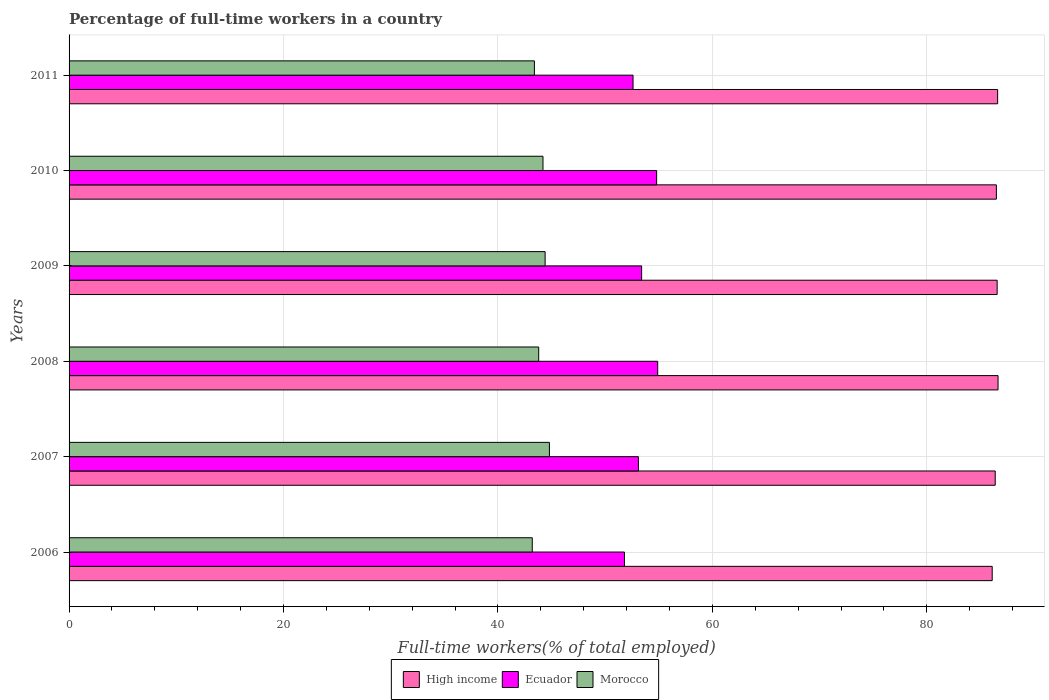How many different coloured bars are there?
Your answer should be compact. 3. How many bars are there on the 5th tick from the top?
Offer a terse response. 3. How many bars are there on the 3rd tick from the bottom?
Give a very brief answer. 3. What is the percentage of full-time workers in Ecuador in 2010?
Your answer should be compact. 54.8. Across all years, what is the maximum percentage of full-time workers in High income?
Offer a terse response. 86.64. Across all years, what is the minimum percentage of full-time workers in Morocco?
Your response must be concise. 43.2. What is the total percentage of full-time workers in Morocco in the graph?
Make the answer very short. 263.8. What is the difference between the percentage of full-time workers in Ecuador in 2006 and that in 2011?
Your response must be concise. -0.8. What is the difference between the percentage of full-time workers in Ecuador in 2010 and the percentage of full-time workers in Morocco in 2011?
Keep it short and to the point. 11.4. What is the average percentage of full-time workers in Morocco per year?
Offer a terse response. 43.97. In the year 2007, what is the difference between the percentage of full-time workers in Morocco and percentage of full-time workers in Ecuador?
Provide a succinct answer. -8.3. What is the ratio of the percentage of full-time workers in Ecuador in 2009 to that in 2010?
Your answer should be very brief. 0.97. Is the percentage of full-time workers in Ecuador in 2006 less than that in 2010?
Ensure brevity in your answer.  Yes. Is the difference between the percentage of full-time workers in Morocco in 2010 and 2011 greater than the difference between the percentage of full-time workers in Ecuador in 2010 and 2011?
Keep it short and to the point. No. What is the difference between the highest and the second highest percentage of full-time workers in Morocco?
Keep it short and to the point. 0.4. What is the difference between the highest and the lowest percentage of full-time workers in Ecuador?
Give a very brief answer. 3.1. In how many years, is the percentage of full-time workers in Morocco greater than the average percentage of full-time workers in Morocco taken over all years?
Provide a succinct answer. 3. Is the sum of the percentage of full-time workers in High income in 2006 and 2007 greater than the maximum percentage of full-time workers in Ecuador across all years?
Ensure brevity in your answer.  Yes. What does the 1st bar from the top in 2006 represents?
Provide a short and direct response. Morocco. What does the 2nd bar from the bottom in 2009 represents?
Give a very brief answer. Ecuador. How many bars are there?
Provide a succinct answer. 18. Are all the bars in the graph horizontal?
Ensure brevity in your answer.  Yes. Does the graph contain any zero values?
Make the answer very short. No. What is the title of the graph?
Make the answer very short. Percentage of full-time workers in a country. Does "Argentina" appear as one of the legend labels in the graph?
Make the answer very short. No. What is the label or title of the X-axis?
Keep it short and to the point. Full-time workers(% of total employed). What is the Full-time workers(% of total employed) in High income in 2006?
Make the answer very short. 86.1. What is the Full-time workers(% of total employed) in Ecuador in 2006?
Offer a very short reply. 51.8. What is the Full-time workers(% of total employed) of Morocco in 2006?
Ensure brevity in your answer.  43.2. What is the Full-time workers(% of total employed) in High income in 2007?
Offer a terse response. 86.38. What is the Full-time workers(% of total employed) of Ecuador in 2007?
Offer a terse response. 53.1. What is the Full-time workers(% of total employed) of Morocco in 2007?
Give a very brief answer. 44.8. What is the Full-time workers(% of total employed) of High income in 2008?
Your answer should be very brief. 86.64. What is the Full-time workers(% of total employed) of Ecuador in 2008?
Your answer should be compact. 54.9. What is the Full-time workers(% of total employed) in Morocco in 2008?
Offer a terse response. 43.8. What is the Full-time workers(% of total employed) in High income in 2009?
Your answer should be very brief. 86.56. What is the Full-time workers(% of total employed) of Ecuador in 2009?
Your answer should be very brief. 53.4. What is the Full-time workers(% of total employed) in Morocco in 2009?
Offer a very short reply. 44.4. What is the Full-time workers(% of total employed) in High income in 2010?
Offer a very short reply. 86.49. What is the Full-time workers(% of total employed) of Ecuador in 2010?
Make the answer very short. 54.8. What is the Full-time workers(% of total employed) of Morocco in 2010?
Ensure brevity in your answer.  44.2. What is the Full-time workers(% of total employed) of High income in 2011?
Make the answer very short. 86.61. What is the Full-time workers(% of total employed) of Ecuador in 2011?
Keep it short and to the point. 52.6. What is the Full-time workers(% of total employed) in Morocco in 2011?
Offer a very short reply. 43.4. Across all years, what is the maximum Full-time workers(% of total employed) in High income?
Provide a short and direct response. 86.64. Across all years, what is the maximum Full-time workers(% of total employed) in Ecuador?
Your answer should be very brief. 54.9. Across all years, what is the maximum Full-time workers(% of total employed) of Morocco?
Ensure brevity in your answer.  44.8. Across all years, what is the minimum Full-time workers(% of total employed) of High income?
Give a very brief answer. 86.1. Across all years, what is the minimum Full-time workers(% of total employed) in Ecuador?
Provide a short and direct response. 51.8. Across all years, what is the minimum Full-time workers(% of total employed) in Morocco?
Your answer should be compact. 43.2. What is the total Full-time workers(% of total employed) in High income in the graph?
Your answer should be very brief. 518.77. What is the total Full-time workers(% of total employed) in Ecuador in the graph?
Ensure brevity in your answer.  320.6. What is the total Full-time workers(% of total employed) of Morocco in the graph?
Your answer should be compact. 263.8. What is the difference between the Full-time workers(% of total employed) in High income in 2006 and that in 2007?
Your response must be concise. -0.28. What is the difference between the Full-time workers(% of total employed) in Morocco in 2006 and that in 2007?
Offer a terse response. -1.6. What is the difference between the Full-time workers(% of total employed) of High income in 2006 and that in 2008?
Provide a short and direct response. -0.54. What is the difference between the Full-time workers(% of total employed) of Ecuador in 2006 and that in 2008?
Your answer should be compact. -3.1. What is the difference between the Full-time workers(% of total employed) in High income in 2006 and that in 2009?
Offer a very short reply. -0.46. What is the difference between the Full-time workers(% of total employed) in High income in 2006 and that in 2010?
Offer a terse response. -0.39. What is the difference between the Full-time workers(% of total employed) of High income in 2006 and that in 2011?
Provide a succinct answer. -0.51. What is the difference between the Full-time workers(% of total employed) in Ecuador in 2006 and that in 2011?
Give a very brief answer. -0.8. What is the difference between the Full-time workers(% of total employed) of Morocco in 2006 and that in 2011?
Ensure brevity in your answer.  -0.2. What is the difference between the Full-time workers(% of total employed) in High income in 2007 and that in 2008?
Make the answer very short. -0.26. What is the difference between the Full-time workers(% of total employed) of Ecuador in 2007 and that in 2008?
Ensure brevity in your answer.  -1.8. What is the difference between the Full-time workers(% of total employed) of Morocco in 2007 and that in 2008?
Your response must be concise. 1. What is the difference between the Full-time workers(% of total employed) in High income in 2007 and that in 2009?
Your answer should be compact. -0.18. What is the difference between the Full-time workers(% of total employed) in Ecuador in 2007 and that in 2009?
Make the answer very short. -0.3. What is the difference between the Full-time workers(% of total employed) in High income in 2007 and that in 2010?
Provide a succinct answer. -0.11. What is the difference between the Full-time workers(% of total employed) in Ecuador in 2007 and that in 2010?
Your answer should be compact. -1.7. What is the difference between the Full-time workers(% of total employed) in High income in 2007 and that in 2011?
Your answer should be very brief. -0.23. What is the difference between the Full-time workers(% of total employed) in Ecuador in 2007 and that in 2011?
Offer a very short reply. 0.5. What is the difference between the Full-time workers(% of total employed) of Morocco in 2007 and that in 2011?
Keep it short and to the point. 1.4. What is the difference between the Full-time workers(% of total employed) in High income in 2008 and that in 2009?
Ensure brevity in your answer.  0.08. What is the difference between the Full-time workers(% of total employed) in Ecuador in 2008 and that in 2009?
Provide a short and direct response. 1.5. What is the difference between the Full-time workers(% of total employed) of Morocco in 2008 and that in 2009?
Your response must be concise. -0.6. What is the difference between the Full-time workers(% of total employed) in High income in 2008 and that in 2010?
Offer a terse response. 0.16. What is the difference between the Full-time workers(% of total employed) of High income in 2008 and that in 2011?
Give a very brief answer. 0.04. What is the difference between the Full-time workers(% of total employed) in Ecuador in 2008 and that in 2011?
Provide a short and direct response. 2.3. What is the difference between the Full-time workers(% of total employed) in Morocco in 2008 and that in 2011?
Ensure brevity in your answer.  0.4. What is the difference between the Full-time workers(% of total employed) in High income in 2009 and that in 2010?
Your response must be concise. 0.07. What is the difference between the Full-time workers(% of total employed) in Morocco in 2009 and that in 2010?
Your answer should be compact. 0.2. What is the difference between the Full-time workers(% of total employed) in High income in 2009 and that in 2011?
Offer a terse response. -0.05. What is the difference between the Full-time workers(% of total employed) in Ecuador in 2009 and that in 2011?
Your answer should be very brief. 0.8. What is the difference between the Full-time workers(% of total employed) of High income in 2010 and that in 2011?
Ensure brevity in your answer.  -0.12. What is the difference between the Full-time workers(% of total employed) of Ecuador in 2010 and that in 2011?
Keep it short and to the point. 2.2. What is the difference between the Full-time workers(% of total employed) of Morocco in 2010 and that in 2011?
Your answer should be very brief. 0.8. What is the difference between the Full-time workers(% of total employed) in High income in 2006 and the Full-time workers(% of total employed) in Ecuador in 2007?
Provide a succinct answer. 33. What is the difference between the Full-time workers(% of total employed) in High income in 2006 and the Full-time workers(% of total employed) in Morocco in 2007?
Ensure brevity in your answer.  41.3. What is the difference between the Full-time workers(% of total employed) in High income in 2006 and the Full-time workers(% of total employed) in Ecuador in 2008?
Offer a terse response. 31.2. What is the difference between the Full-time workers(% of total employed) of High income in 2006 and the Full-time workers(% of total employed) of Morocco in 2008?
Make the answer very short. 42.3. What is the difference between the Full-time workers(% of total employed) in High income in 2006 and the Full-time workers(% of total employed) in Ecuador in 2009?
Give a very brief answer. 32.7. What is the difference between the Full-time workers(% of total employed) of High income in 2006 and the Full-time workers(% of total employed) of Morocco in 2009?
Ensure brevity in your answer.  41.7. What is the difference between the Full-time workers(% of total employed) of Ecuador in 2006 and the Full-time workers(% of total employed) of Morocco in 2009?
Offer a very short reply. 7.4. What is the difference between the Full-time workers(% of total employed) of High income in 2006 and the Full-time workers(% of total employed) of Ecuador in 2010?
Ensure brevity in your answer.  31.3. What is the difference between the Full-time workers(% of total employed) of High income in 2006 and the Full-time workers(% of total employed) of Morocco in 2010?
Your answer should be very brief. 41.9. What is the difference between the Full-time workers(% of total employed) in Ecuador in 2006 and the Full-time workers(% of total employed) in Morocco in 2010?
Your answer should be very brief. 7.6. What is the difference between the Full-time workers(% of total employed) in High income in 2006 and the Full-time workers(% of total employed) in Ecuador in 2011?
Your answer should be very brief. 33.5. What is the difference between the Full-time workers(% of total employed) in High income in 2006 and the Full-time workers(% of total employed) in Morocco in 2011?
Your answer should be very brief. 42.7. What is the difference between the Full-time workers(% of total employed) in Ecuador in 2006 and the Full-time workers(% of total employed) in Morocco in 2011?
Give a very brief answer. 8.4. What is the difference between the Full-time workers(% of total employed) in High income in 2007 and the Full-time workers(% of total employed) in Ecuador in 2008?
Give a very brief answer. 31.48. What is the difference between the Full-time workers(% of total employed) of High income in 2007 and the Full-time workers(% of total employed) of Morocco in 2008?
Provide a succinct answer. 42.58. What is the difference between the Full-time workers(% of total employed) in High income in 2007 and the Full-time workers(% of total employed) in Ecuador in 2009?
Offer a terse response. 32.98. What is the difference between the Full-time workers(% of total employed) of High income in 2007 and the Full-time workers(% of total employed) of Morocco in 2009?
Provide a short and direct response. 41.98. What is the difference between the Full-time workers(% of total employed) of Ecuador in 2007 and the Full-time workers(% of total employed) of Morocco in 2009?
Your response must be concise. 8.7. What is the difference between the Full-time workers(% of total employed) of High income in 2007 and the Full-time workers(% of total employed) of Ecuador in 2010?
Your answer should be compact. 31.58. What is the difference between the Full-time workers(% of total employed) of High income in 2007 and the Full-time workers(% of total employed) of Morocco in 2010?
Your answer should be compact. 42.18. What is the difference between the Full-time workers(% of total employed) in High income in 2007 and the Full-time workers(% of total employed) in Ecuador in 2011?
Your answer should be compact. 33.78. What is the difference between the Full-time workers(% of total employed) of High income in 2007 and the Full-time workers(% of total employed) of Morocco in 2011?
Provide a short and direct response. 42.98. What is the difference between the Full-time workers(% of total employed) in High income in 2008 and the Full-time workers(% of total employed) in Ecuador in 2009?
Keep it short and to the point. 33.24. What is the difference between the Full-time workers(% of total employed) in High income in 2008 and the Full-time workers(% of total employed) in Morocco in 2009?
Make the answer very short. 42.24. What is the difference between the Full-time workers(% of total employed) in High income in 2008 and the Full-time workers(% of total employed) in Ecuador in 2010?
Make the answer very short. 31.84. What is the difference between the Full-time workers(% of total employed) in High income in 2008 and the Full-time workers(% of total employed) in Morocco in 2010?
Make the answer very short. 42.44. What is the difference between the Full-time workers(% of total employed) of Ecuador in 2008 and the Full-time workers(% of total employed) of Morocco in 2010?
Provide a short and direct response. 10.7. What is the difference between the Full-time workers(% of total employed) in High income in 2008 and the Full-time workers(% of total employed) in Ecuador in 2011?
Give a very brief answer. 34.04. What is the difference between the Full-time workers(% of total employed) of High income in 2008 and the Full-time workers(% of total employed) of Morocco in 2011?
Offer a terse response. 43.24. What is the difference between the Full-time workers(% of total employed) in High income in 2009 and the Full-time workers(% of total employed) in Ecuador in 2010?
Offer a terse response. 31.76. What is the difference between the Full-time workers(% of total employed) in High income in 2009 and the Full-time workers(% of total employed) in Morocco in 2010?
Provide a short and direct response. 42.36. What is the difference between the Full-time workers(% of total employed) in Ecuador in 2009 and the Full-time workers(% of total employed) in Morocco in 2010?
Keep it short and to the point. 9.2. What is the difference between the Full-time workers(% of total employed) in High income in 2009 and the Full-time workers(% of total employed) in Ecuador in 2011?
Offer a terse response. 33.96. What is the difference between the Full-time workers(% of total employed) in High income in 2009 and the Full-time workers(% of total employed) in Morocco in 2011?
Keep it short and to the point. 43.16. What is the difference between the Full-time workers(% of total employed) of Ecuador in 2009 and the Full-time workers(% of total employed) of Morocco in 2011?
Provide a succinct answer. 10. What is the difference between the Full-time workers(% of total employed) in High income in 2010 and the Full-time workers(% of total employed) in Ecuador in 2011?
Give a very brief answer. 33.89. What is the difference between the Full-time workers(% of total employed) of High income in 2010 and the Full-time workers(% of total employed) of Morocco in 2011?
Offer a terse response. 43.09. What is the difference between the Full-time workers(% of total employed) of Ecuador in 2010 and the Full-time workers(% of total employed) of Morocco in 2011?
Offer a terse response. 11.4. What is the average Full-time workers(% of total employed) in High income per year?
Offer a terse response. 86.46. What is the average Full-time workers(% of total employed) of Ecuador per year?
Your answer should be very brief. 53.43. What is the average Full-time workers(% of total employed) of Morocco per year?
Make the answer very short. 43.97. In the year 2006, what is the difference between the Full-time workers(% of total employed) of High income and Full-time workers(% of total employed) of Ecuador?
Offer a very short reply. 34.3. In the year 2006, what is the difference between the Full-time workers(% of total employed) of High income and Full-time workers(% of total employed) of Morocco?
Ensure brevity in your answer.  42.9. In the year 2007, what is the difference between the Full-time workers(% of total employed) in High income and Full-time workers(% of total employed) in Ecuador?
Your answer should be very brief. 33.28. In the year 2007, what is the difference between the Full-time workers(% of total employed) in High income and Full-time workers(% of total employed) in Morocco?
Your response must be concise. 41.58. In the year 2007, what is the difference between the Full-time workers(% of total employed) of Ecuador and Full-time workers(% of total employed) of Morocco?
Offer a terse response. 8.3. In the year 2008, what is the difference between the Full-time workers(% of total employed) in High income and Full-time workers(% of total employed) in Ecuador?
Provide a short and direct response. 31.74. In the year 2008, what is the difference between the Full-time workers(% of total employed) of High income and Full-time workers(% of total employed) of Morocco?
Your answer should be very brief. 42.84. In the year 2009, what is the difference between the Full-time workers(% of total employed) of High income and Full-time workers(% of total employed) of Ecuador?
Give a very brief answer. 33.16. In the year 2009, what is the difference between the Full-time workers(% of total employed) of High income and Full-time workers(% of total employed) of Morocco?
Give a very brief answer. 42.16. In the year 2009, what is the difference between the Full-time workers(% of total employed) in Ecuador and Full-time workers(% of total employed) in Morocco?
Your answer should be compact. 9. In the year 2010, what is the difference between the Full-time workers(% of total employed) of High income and Full-time workers(% of total employed) of Ecuador?
Your response must be concise. 31.69. In the year 2010, what is the difference between the Full-time workers(% of total employed) of High income and Full-time workers(% of total employed) of Morocco?
Provide a succinct answer. 42.29. In the year 2010, what is the difference between the Full-time workers(% of total employed) of Ecuador and Full-time workers(% of total employed) of Morocco?
Ensure brevity in your answer.  10.6. In the year 2011, what is the difference between the Full-time workers(% of total employed) in High income and Full-time workers(% of total employed) in Ecuador?
Provide a short and direct response. 34.01. In the year 2011, what is the difference between the Full-time workers(% of total employed) in High income and Full-time workers(% of total employed) in Morocco?
Ensure brevity in your answer.  43.2. In the year 2011, what is the difference between the Full-time workers(% of total employed) of Ecuador and Full-time workers(% of total employed) of Morocco?
Your answer should be compact. 9.2. What is the ratio of the Full-time workers(% of total employed) of Ecuador in 2006 to that in 2007?
Provide a short and direct response. 0.98. What is the ratio of the Full-time workers(% of total employed) of Ecuador in 2006 to that in 2008?
Your response must be concise. 0.94. What is the ratio of the Full-time workers(% of total employed) in Morocco in 2006 to that in 2008?
Your response must be concise. 0.99. What is the ratio of the Full-time workers(% of total employed) of High income in 2006 to that in 2009?
Your response must be concise. 0.99. What is the ratio of the Full-time workers(% of total employed) in Ecuador in 2006 to that in 2009?
Make the answer very short. 0.97. What is the ratio of the Full-time workers(% of total employed) in Morocco in 2006 to that in 2009?
Provide a short and direct response. 0.97. What is the ratio of the Full-time workers(% of total employed) in Ecuador in 2006 to that in 2010?
Provide a succinct answer. 0.95. What is the ratio of the Full-time workers(% of total employed) of Morocco in 2006 to that in 2010?
Provide a short and direct response. 0.98. What is the ratio of the Full-time workers(% of total employed) of High income in 2006 to that in 2011?
Provide a succinct answer. 0.99. What is the ratio of the Full-time workers(% of total employed) in Morocco in 2006 to that in 2011?
Offer a very short reply. 1. What is the ratio of the Full-time workers(% of total employed) in High income in 2007 to that in 2008?
Ensure brevity in your answer.  1. What is the ratio of the Full-time workers(% of total employed) in Ecuador in 2007 to that in 2008?
Offer a terse response. 0.97. What is the ratio of the Full-time workers(% of total employed) of Morocco in 2007 to that in 2008?
Give a very brief answer. 1.02. What is the ratio of the Full-time workers(% of total employed) of High income in 2007 to that in 2009?
Offer a terse response. 1. What is the ratio of the Full-time workers(% of total employed) in Ecuador in 2007 to that in 2009?
Provide a short and direct response. 0.99. What is the ratio of the Full-time workers(% of total employed) of High income in 2007 to that in 2010?
Ensure brevity in your answer.  1. What is the ratio of the Full-time workers(% of total employed) of Morocco in 2007 to that in 2010?
Provide a succinct answer. 1.01. What is the ratio of the Full-time workers(% of total employed) in Ecuador in 2007 to that in 2011?
Provide a short and direct response. 1.01. What is the ratio of the Full-time workers(% of total employed) of Morocco in 2007 to that in 2011?
Your response must be concise. 1.03. What is the ratio of the Full-time workers(% of total employed) of Ecuador in 2008 to that in 2009?
Make the answer very short. 1.03. What is the ratio of the Full-time workers(% of total employed) of Morocco in 2008 to that in 2009?
Your answer should be compact. 0.99. What is the ratio of the Full-time workers(% of total employed) in High income in 2008 to that in 2011?
Provide a succinct answer. 1. What is the ratio of the Full-time workers(% of total employed) in Ecuador in 2008 to that in 2011?
Your response must be concise. 1.04. What is the ratio of the Full-time workers(% of total employed) of Morocco in 2008 to that in 2011?
Offer a very short reply. 1.01. What is the ratio of the Full-time workers(% of total employed) of Ecuador in 2009 to that in 2010?
Offer a terse response. 0.97. What is the ratio of the Full-time workers(% of total employed) of High income in 2009 to that in 2011?
Keep it short and to the point. 1. What is the ratio of the Full-time workers(% of total employed) in Ecuador in 2009 to that in 2011?
Keep it short and to the point. 1.02. What is the ratio of the Full-time workers(% of total employed) in High income in 2010 to that in 2011?
Offer a terse response. 1. What is the ratio of the Full-time workers(% of total employed) in Ecuador in 2010 to that in 2011?
Offer a terse response. 1.04. What is the ratio of the Full-time workers(% of total employed) of Morocco in 2010 to that in 2011?
Offer a terse response. 1.02. What is the difference between the highest and the second highest Full-time workers(% of total employed) in High income?
Keep it short and to the point. 0.04. What is the difference between the highest and the second highest Full-time workers(% of total employed) in Morocco?
Provide a succinct answer. 0.4. What is the difference between the highest and the lowest Full-time workers(% of total employed) in High income?
Offer a terse response. 0.54. What is the difference between the highest and the lowest Full-time workers(% of total employed) of Ecuador?
Offer a terse response. 3.1. What is the difference between the highest and the lowest Full-time workers(% of total employed) in Morocco?
Ensure brevity in your answer.  1.6. 